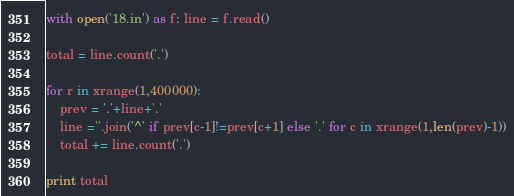Convert code to text. <code><loc_0><loc_0><loc_500><loc_500><_Python_>with open('18.in') as f: line = f.read()

total = line.count('.')

for r in xrange(1,400000):
	prev = '.'+line+'.'
	line =''.join('^' if prev[c-1]!=prev[c+1] else '.' for c in xrange(1,len(prev)-1))
	total += line.count('.')

print total</code> 